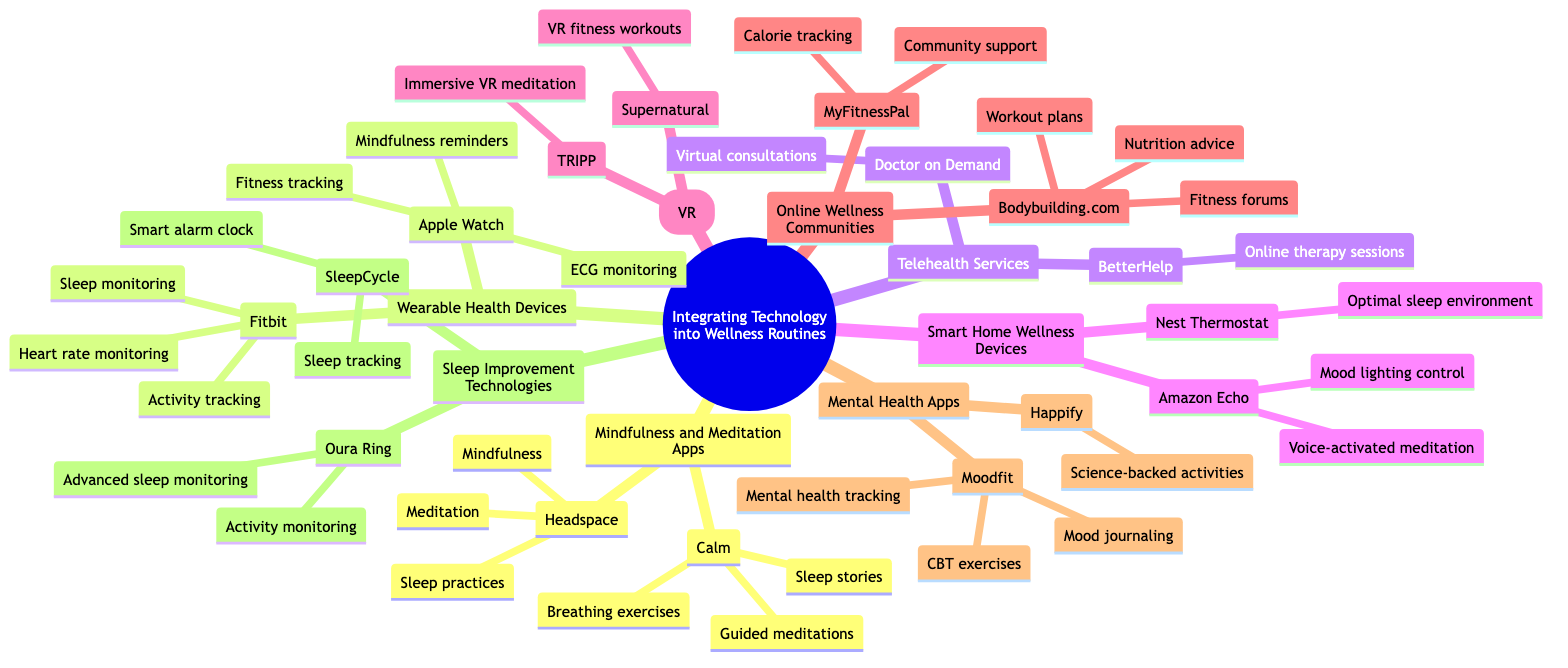What are the two mindfulness and meditation apps mentioned? The diagram lists "Calm" and "Headspace" under the "Mindfulness and Meditation Apps" category.
Answer: Calm, Headspace How many online wellness communities are included? The diagram shows "Bodybuilding.com" and "MyFitnessPal" as the two specific communities listed under the "Online Wellness Communities" section.
Answer: 2 What type of technology does SleepCycle represent? The "Sleep Improvement Technologies" section specifies that SleepCycle is categorized as a smart alarm clock and sleep tracking device.
Answer: Sleep Improvement Technologies Which wearable health device offers ECG monitoring? Under the "Wearable Health Devices," the "Apple Watch" is specifically stated to provide ECG monitoring.
Answer: Apple Watch What is a feature of the Amazon Echo in wellness routines? The "Amazon Echo," listed under "Smart Home Wellness Devices," is noted for its ability to provide voice-activated meditation sessions.
Answer: Voice-activated meditation What type of experiences does TRIPP offer? In the "Virtual Reality (VR)" section, TRIPP is described as providing immersive VR meditation experiences.
Answer: Immersive VR meditation Which mental health app includes CBT exercises? The diagram notes that "Moodfit" offers CBT exercises as part of its features in the "Mental Health Apps" category.
Answer: Moodfit How many distinct categories are there in the diagram? The diagram presents a total of eight distinct categories under "Integrating Technology into Wellness Routines," including all subcategories.
Answer: 8 Which device controls temperature for sleep? "Nest Thermostat" is indicated under "Smart Home Wellness Devices" as providing temperature control for an optimal sleep environment.
Answer: Nest Thermostat 